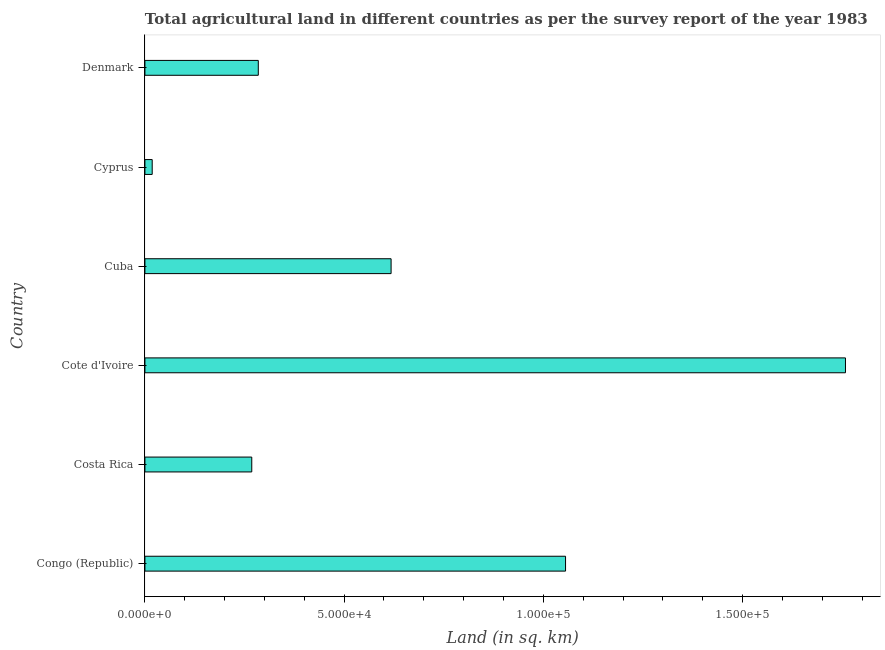Does the graph contain any zero values?
Keep it short and to the point. No. What is the title of the graph?
Make the answer very short. Total agricultural land in different countries as per the survey report of the year 1983. What is the label or title of the X-axis?
Your response must be concise. Land (in sq. km). What is the label or title of the Y-axis?
Offer a very short reply. Country. What is the agricultural land in Cote d'Ivoire?
Offer a terse response. 1.76e+05. Across all countries, what is the maximum agricultural land?
Provide a short and direct response. 1.76e+05. Across all countries, what is the minimum agricultural land?
Make the answer very short. 1830. In which country was the agricultural land maximum?
Your response must be concise. Cote d'Ivoire. In which country was the agricultural land minimum?
Provide a succinct answer. Cyprus. What is the sum of the agricultural land?
Your answer should be compact. 4.00e+05. What is the difference between the agricultural land in Costa Rica and Cuba?
Provide a short and direct response. -3.50e+04. What is the average agricultural land per country?
Your answer should be very brief. 6.67e+04. What is the median agricultural land?
Your answer should be compact. 4.51e+04. In how many countries, is the agricultural land greater than 140000 sq. km?
Your answer should be very brief. 1. What is the ratio of the agricultural land in Cote d'Ivoire to that in Denmark?
Make the answer very short. 6.18. Is the agricultural land in Congo (Republic) less than that in Cyprus?
Provide a short and direct response. No. Is the difference between the agricultural land in Cyprus and Denmark greater than the difference between any two countries?
Give a very brief answer. No. What is the difference between the highest and the second highest agricultural land?
Offer a very short reply. 7.03e+04. What is the difference between the highest and the lowest agricultural land?
Your answer should be very brief. 1.74e+05. In how many countries, is the agricultural land greater than the average agricultural land taken over all countries?
Your answer should be compact. 2. What is the difference between two consecutive major ticks on the X-axis?
Your response must be concise. 5.00e+04. Are the values on the major ticks of X-axis written in scientific E-notation?
Provide a short and direct response. Yes. What is the Land (in sq. km) of Congo (Republic)?
Your answer should be compact. 1.06e+05. What is the Land (in sq. km) in Costa Rica?
Give a very brief answer. 2.68e+04. What is the Land (in sq. km) of Cote d'Ivoire?
Your answer should be compact. 1.76e+05. What is the Land (in sq. km) in Cuba?
Make the answer very short. 6.18e+04. What is the Land (in sq. km) in Cyprus?
Your answer should be very brief. 1830. What is the Land (in sq. km) of Denmark?
Give a very brief answer. 2.85e+04. What is the difference between the Land (in sq. km) in Congo (Republic) and Costa Rica?
Your answer should be compact. 7.88e+04. What is the difference between the Land (in sq. km) in Congo (Republic) and Cote d'Ivoire?
Provide a succinct answer. -7.03e+04. What is the difference between the Land (in sq. km) in Congo (Republic) and Cuba?
Offer a terse response. 4.38e+04. What is the difference between the Land (in sq. km) in Congo (Republic) and Cyprus?
Provide a succinct answer. 1.04e+05. What is the difference between the Land (in sq. km) in Congo (Republic) and Denmark?
Offer a terse response. 7.71e+04. What is the difference between the Land (in sq. km) in Costa Rica and Cote d'Ivoire?
Provide a short and direct response. -1.49e+05. What is the difference between the Land (in sq. km) in Costa Rica and Cuba?
Your response must be concise. -3.50e+04. What is the difference between the Land (in sq. km) in Costa Rica and Cyprus?
Give a very brief answer. 2.50e+04. What is the difference between the Land (in sq. km) in Costa Rica and Denmark?
Give a very brief answer. -1640. What is the difference between the Land (in sq. km) in Cote d'Ivoire and Cuba?
Provide a short and direct response. 1.14e+05. What is the difference between the Land (in sq. km) in Cote d'Ivoire and Cyprus?
Offer a terse response. 1.74e+05. What is the difference between the Land (in sq. km) in Cote d'Ivoire and Denmark?
Ensure brevity in your answer.  1.47e+05. What is the difference between the Land (in sq. km) in Cuba and Cyprus?
Provide a short and direct response. 6.00e+04. What is the difference between the Land (in sq. km) in Cuba and Denmark?
Ensure brevity in your answer.  3.33e+04. What is the difference between the Land (in sq. km) in Cyprus and Denmark?
Provide a succinct answer. -2.66e+04. What is the ratio of the Land (in sq. km) in Congo (Republic) to that in Costa Rica?
Provide a succinct answer. 3.94. What is the ratio of the Land (in sq. km) in Congo (Republic) to that in Cote d'Ivoire?
Offer a very short reply. 0.6. What is the ratio of the Land (in sq. km) in Congo (Republic) to that in Cuba?
Offer a very short reply. 1.71. What is the ratio of the Land (in sq. km) in Congo (Republic) to that in Cyprus?
Offer a terse response. 57.69. What is the ratio of the Land (in sq. km) in Congo (Republic) to that in Denmark?
Your answer should be compact. 3.71. What is the ratio of the Land (in sq. km) in Costa Rica to that in Cote d'Ivoire?
Keep it short and to the point. 0.15. What is the ratio of the Land (in sq. km) in Costa Rica to that in Cuba?
Offer a very short reply. 0.43. What is the ratio of the Land (in sq. km) in Costa Rica to that in Cyprus?
Ensure brevity in your answer.  14.66. What is the ratio of the Land (in sq. km) in Costa Rica to that in Denmark?
Keep it short and to the point. 0.94. What is the ratio of the Land (in sq. km) in Cote d'Ivoire to that in Cuba?
Keep it short and to the point. 2.85. What is the ratio of the Land (in sq. km) in Cote d'Ivoire to that in Cyprus?
Your answer should be compact. 96.09. What is the ratio of the Land (in sq. km) in Cote d'Ivoire to that in Denmark?
Keep it short and to the point. 6.18. What is the ratio of the Land (in sq. km) in Cuba to that in Cyprus?
Your answer should be very brief. 33.77. What is the ratio of the Land (in sq. km) in Cuba to that in Denmark?
Give a very brief answer. 2.17. What is the ratio of the Land (in sq. km) in Cyprus to that in Denmark?
Provide a short and direct response. 0.06. 